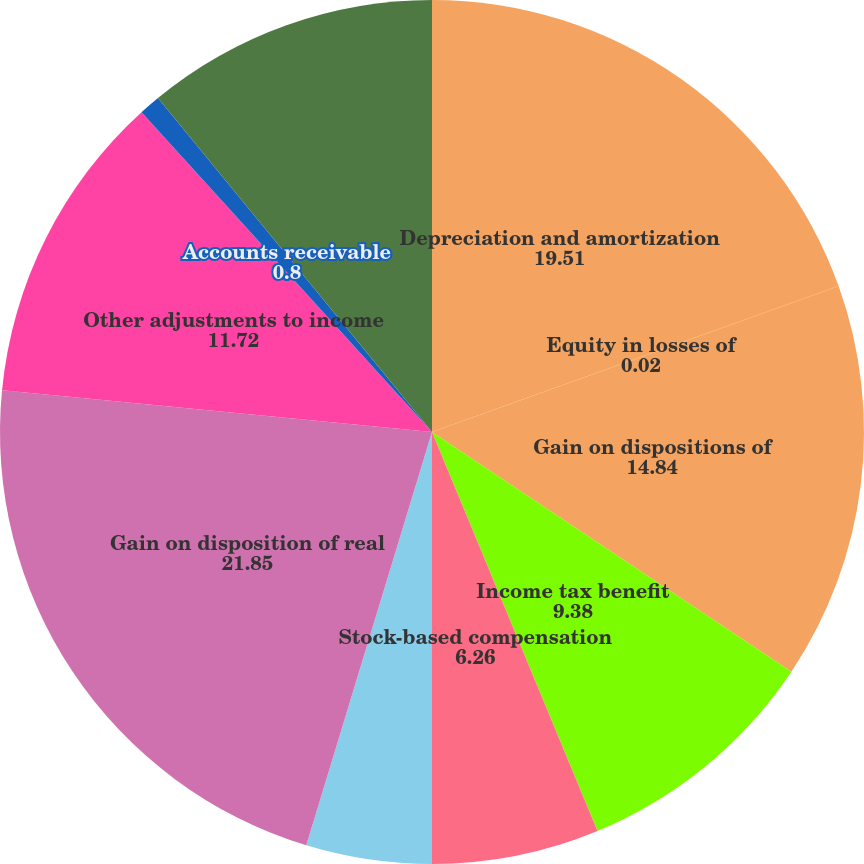Convert chart to OTSL. <chart><loc_0><loc_0><loc_500><loc_500><pie_chart><fcel>Depreciation and amortization<fcel>Equity in losses of<fcel>Gain on dispositions of<fcel>Income tax benefit<fcel>Stock-based compensation<fcel>Amortization of deferred loan<fcel>Gain on disposition of real<fcel>Other adjustments to income<fcel>Accounts receivable<fcel>Other assets<nl><fcel>19.51%<fcel>0.02%<fcel>14.84%<fcel>9.38%<fcel>6.26%<fcel>4.7%<fcel>21.85%<fcel>11.72%<fcel>0.8%<fcel>10.94%<nl></chart> 